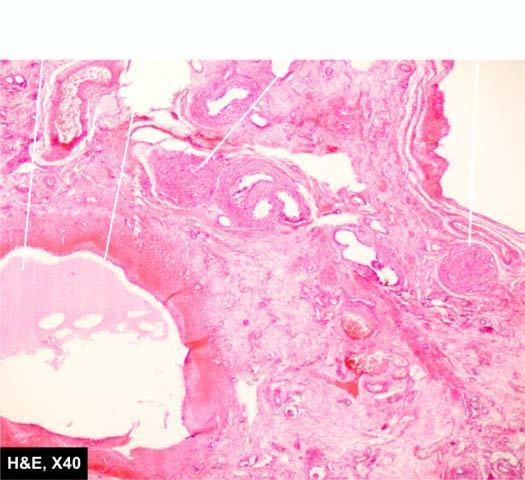what does the intervening parenchyma consist of?
Answer the question using a single word or phrase. Primitive connective tissue and cartilage 